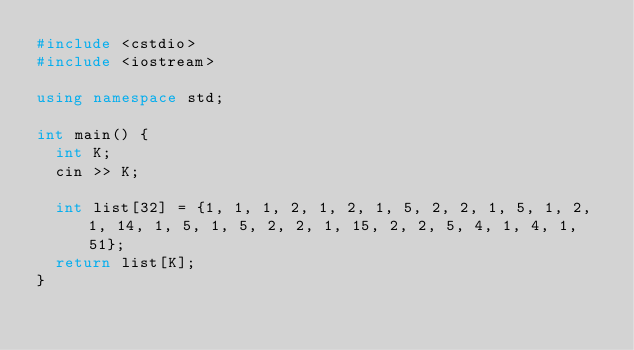<code> <loc_0><loc_0><loc_500><loc_500><_C++_>#include <cstdio>
#include <iostream>

using namespace std;

int main() {
	int K;
	cin >> K;
	
	int list[32] = {1, 1, 1, 2, 1, 2, 1, 5, 2, 2, 1, 5, 1, 2, 1, 14, 1, 5, 1, 5, 2, 2, 1, 15, 2, 2, 5, 4, 1, 4, 1, 51};
	return list[K];
}

</code> 